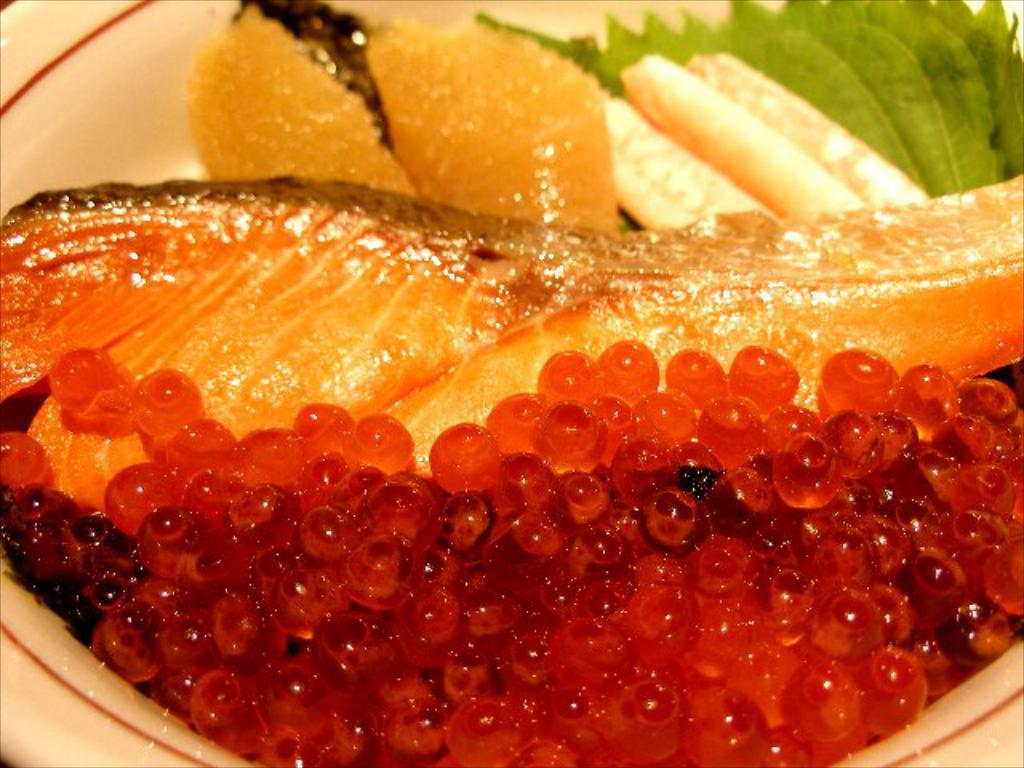What type of eggs can be seen in the image? There are fish eggs in the image. What other seafood item is present in the image? There is a piece of fish in the image. What type of vegetables are in the image? There are green vegetables in the image. What other food items are present in the image? There are other food items in a bowl in the image. What type of juice can be seen in the image? There is no juice present in the image. 